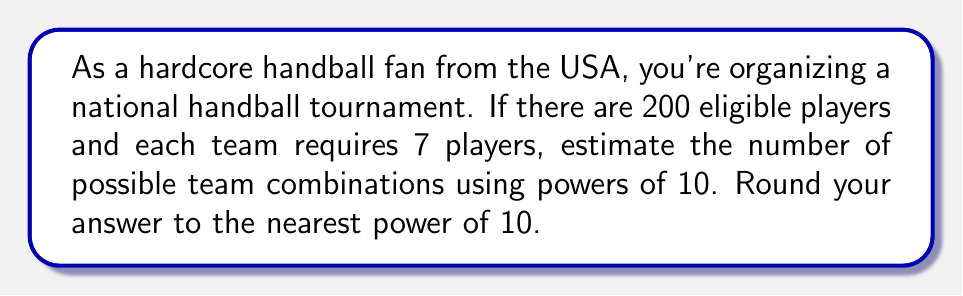Provide a solution to this math problem. Let's approach this step-by-step:

1) We're selecting 7 players from a pool of 200. This is a combination problem, represented by $\binom{200}{7}$.

2) The exact formula for this combination is:

   $$\binom{200}{7} = \frac{200!}{7!(200-7)!} = \frac{200!}{7!193!}$$

3) Calculating this exactly would be time-consuming, so we'll estimate using properties of exponents.

4) We can approximate this using the formula:

   $$\binom{n}{k} \approx \frac{n^k}{k!}$$

5) Plugging in our values:

   $$\binom{200}{7} \approx \frac{200^7}{7!}$$

6) Let's calculate each part:
   
   $200^7 = 1.28 \times 10^{16}$
   
   $7! = 5040$

7) Dividing:

   $$\frac{1.28 \times 10^{16}}{5040} \approx 2.54 \times 10^{12}$$

8) Rounding to the nearest power of 10, we get $10^{13}$.
Answer: $10^{13}$ possible team combinations 